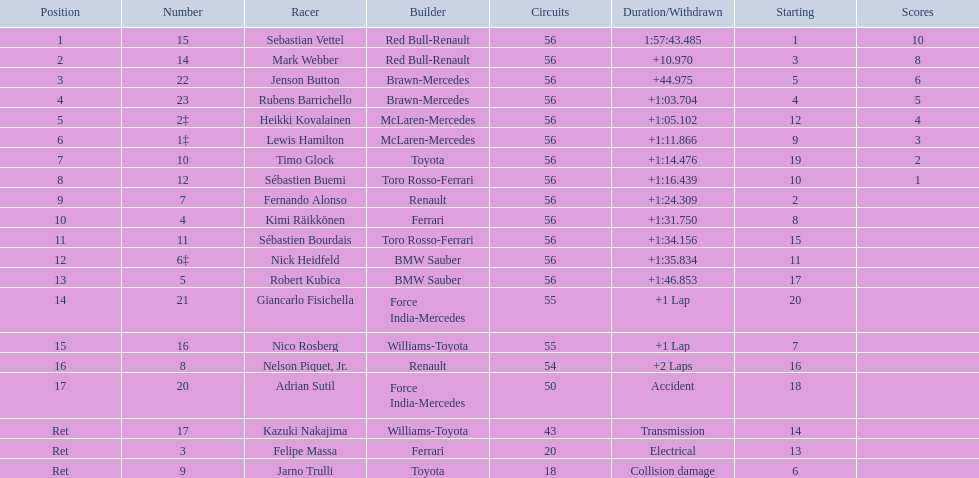Why did the  toyota retire Collision damage. What was the drivers name? Jarno Trulli. 